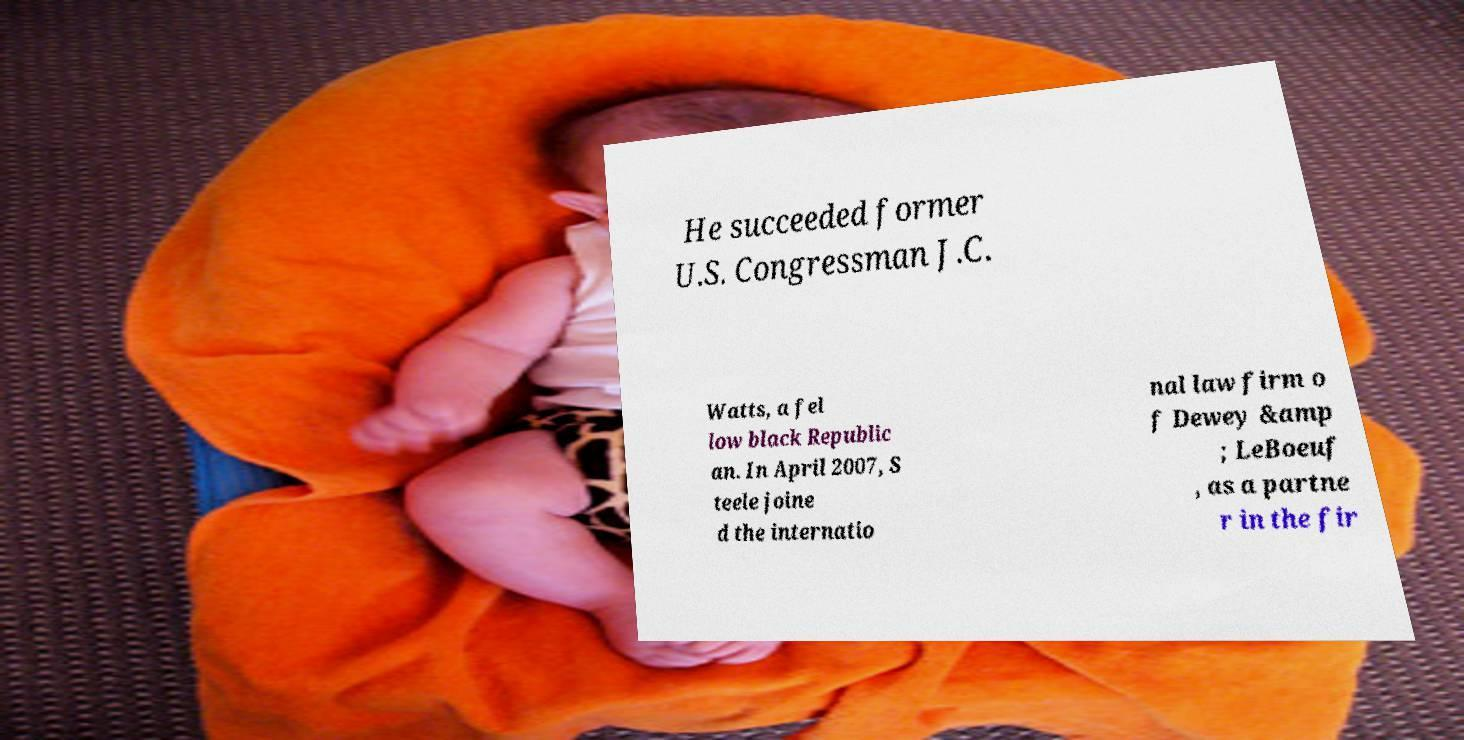For documentation purposes, I need the text within this image transcribed. Could you provide that? He succeeded former U.S. Congressman J.C. Watts, a fel low black Republic an. In April 2007, S teele joine d the internatio nal law firm o f Dewey &amp ; LeBoeuf , as a partne r in the fir 